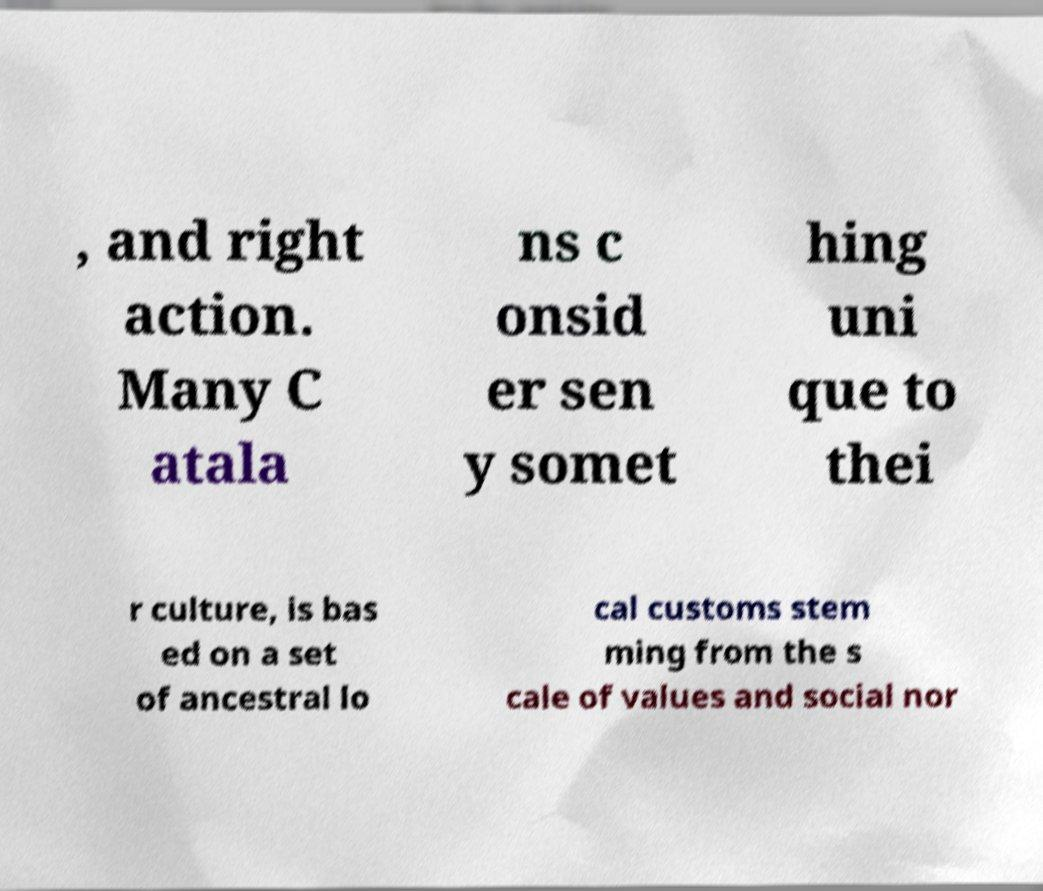Please read and relay the text visible in this image. What does it say? , and right action. Many C atala ns c onsid er sen y somet hing uni que to thei r culture, is bas ed on a set of ancestral lo cal customs stem ming from the s cale of values and social nor 